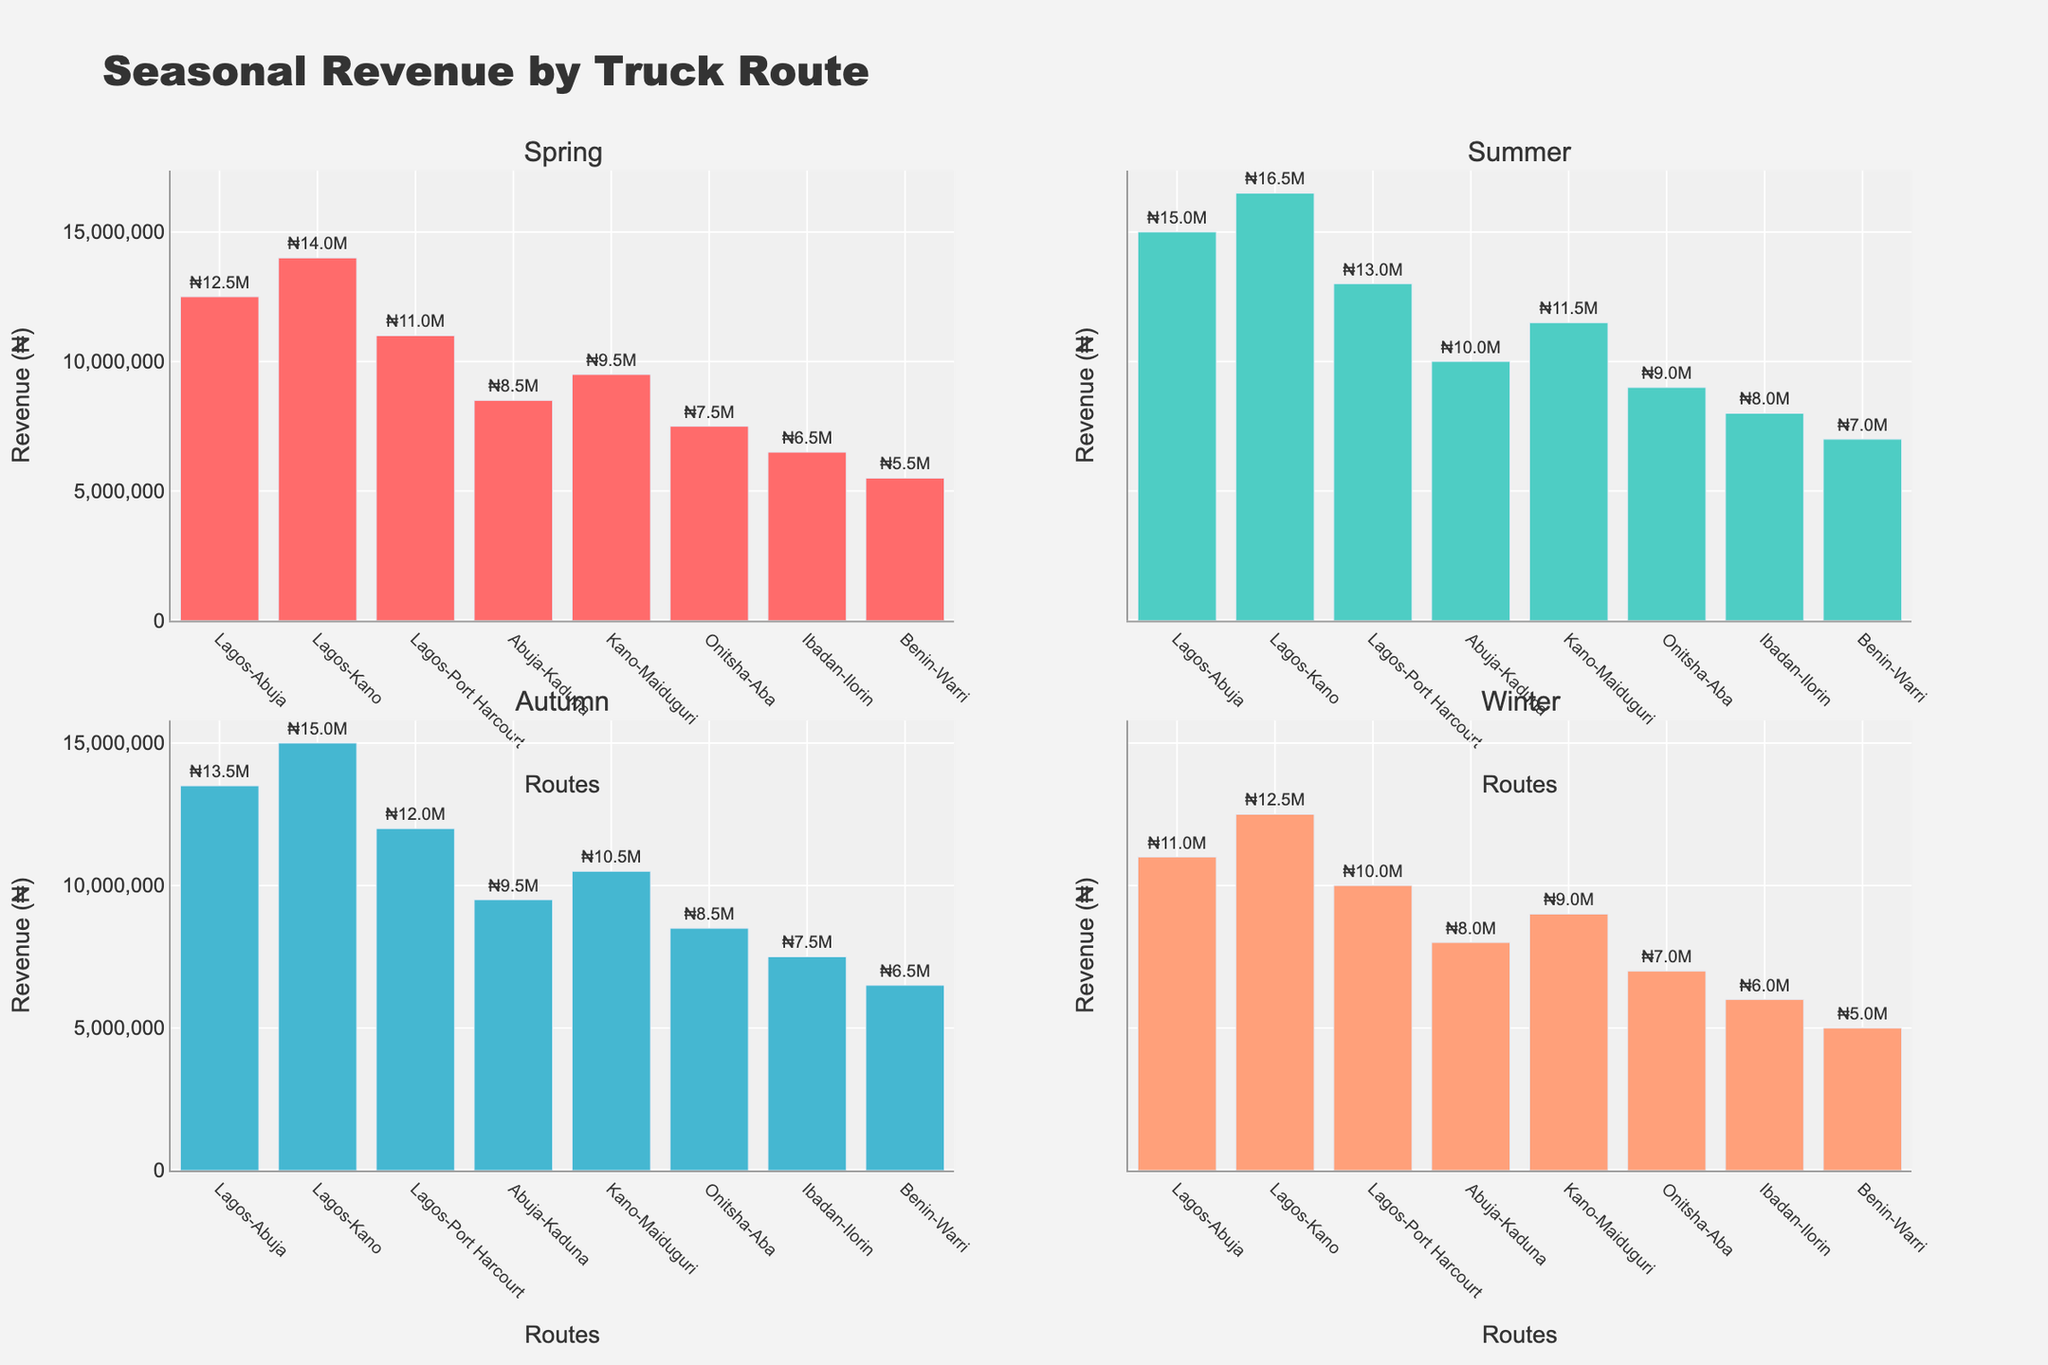Which route generates the most revenue during Summer? Looking at the subplot titled "Summer," the highest bar represents the Lagos-Kano route with a revenue of ₦16.5M.
Answer: Lagos-Kano Which season has the lowest total revenue across all routes? Summing the revenues for each route in each season: Spring (₦69500000), Summer (₦81000000), Autumn (₦73500000), Winter (₦63500000). Winter has the lowest total revenue.
Answer: Winter What is the average revenue generated by the Abuja-Kaduna route across all seasons? Summing the revenues for Abuja-Kaduna (₦8500000 + ₦10000000 + ₦9500000 + ₦8000000 = ₦36000000) and dividing by 4 (₦36000000/4) gives ₦9000000.
Answer: ₦9000000 Which routes generate less than ₦10M in at least one season? Checking each route in each season: Abuja-Kaduna (Winter), Kano-Maiduguri (Spring & Winter), Onitsha-Aba (all seasons), Ibadan-Ilorin (all seasons), Benin-Warri (all seasons).
Answer: Abuja-Kaduna, Kano-Maiduguri, Onitsha-Aba, Ibadan-Ilorin, Benin-Warri In which season is the revenue difference between Lagos-Abuja and Lagos-Port Harcourt the greatest? Calculating differences for each season: Spring (₦12500000 - ₦11000000 = ₦1500000), Summer (₦15000000 - ₦13000000 = ₦2000000), Autumn (₦13500000 - ₦12000000 = ₦1500000), Winter (₦11000000 - ₦10000000 = ₦1000000). The greatest difference is in Summer (₦2000000).
Answer: Summer Which routes consistently generate the lowest revenue across all seasons? Comparing the revenues: Benin-Warri generates the lowest revenue in every season (₦5500000, ₦7000000, ₦6500000, ₦5000000).
Answer: Benin-Warri How does the revenue for Lagos-Abuja route in Winter compare to Summer? Comparing the Winter revenue for Lagos-Abuja (₦11000000) with Summer (₦15000000), we see that Winter revenue is ₦4000000 less than Summer.
Answer: ₦4000000 less Which season has the smallest variance in revenue across all routes? Calculating variance for each season: Spring (20535714285714.285), Summer (23785714285714.285), Autumn (22892857142857.14), Winter (15714285714285.714), Winter has the smallest variance.
Answer: Winter 